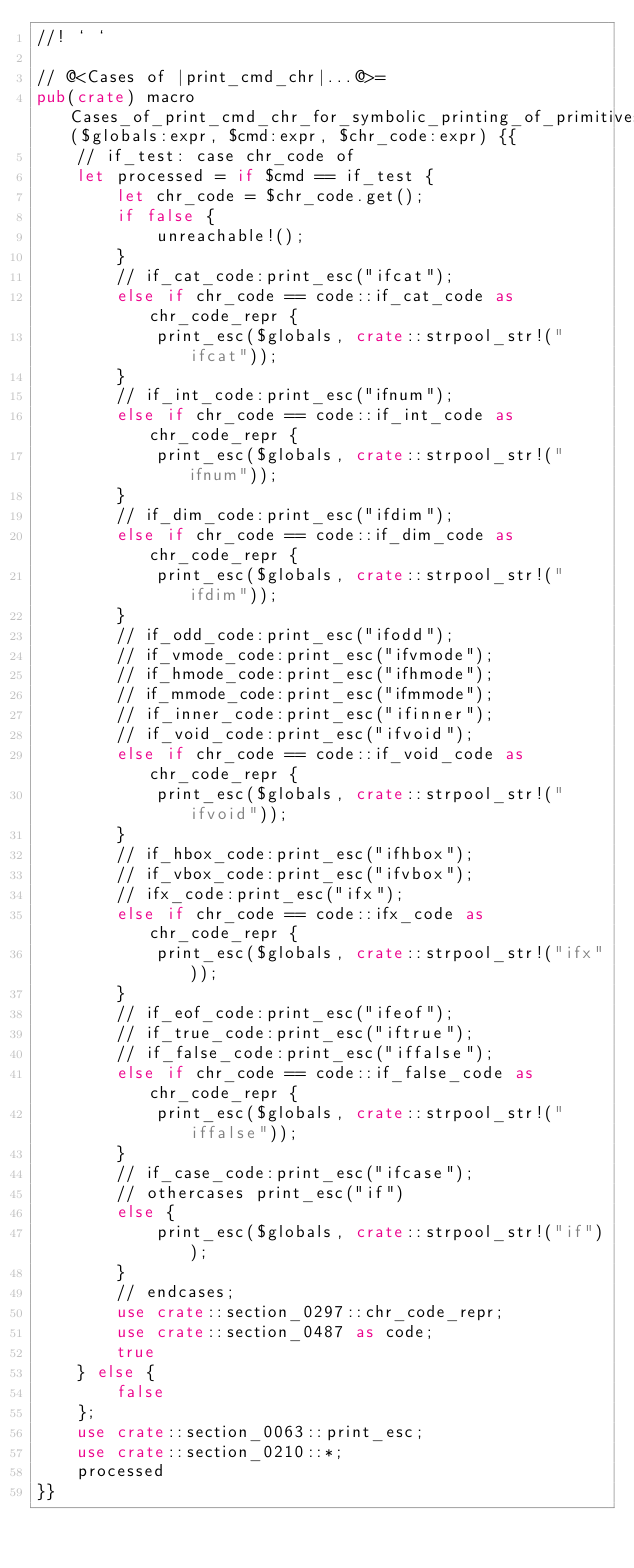Convert code to text. <code><loc_0><loc_0><loc_500><loc_500><_Rust_>//! ` `

// @<Cases of |print_cmd_chr|...@>=
pub(crate) macro Cases_of_print_cmd_chr_for_symbolic_printing_of_primitives_0488($globals:expr, $cmd:expr, $chr_code:expr) {{
    // if_test: case chr_code of
    let processed = if $cmd == if_test {
        let chr_code = $chr_code.get();
        if false {
            unreachable!();
        }
        // if_cat_code:print_esc("ifcat");
        else if chr_code == code::if_cat_code as chr_code_repr {
            print_esc($globals, crate::strpool_str!("ifcat"));
        }
        // if_int_code:print_esc("ifnum");
        else if chr_code == code::if_int_code as chr_code_repr {
            print_esc($globals, crate::strpool_str!("ifnum"));
        }
        // if_dim_code:print_esc("ifdim");
        else if chr_code == code::if_dim_code as chr_code_repr {
            print_esc($globals, crate::strpool_str!("ifdim"));
        }
        // if_odd_code:print_esc("ifodd");
        // if_vmode_code:print_esc("ifvmode");
        // if_hmode_code:print_esc("ifhmode");
        // if_mmode_code:print_esc("ifmmode");
        // if_inner_code:print_esc("ifinner");
        // if_void_code:print_esc("ifvoid");
        else if chr_code == code::if_void_code as chr_code_repr {
            print_esc($globals, crate::strpool_str!("ifvoid"));
        }
        // if_hbox_code:print_esc("ifhbox");
        // if_vbox_code:print_esc("ifvbox");
        // ifx_code:print_esc("ifx");
        else if chr_code == code::ifx_code as chr_code_repr {
            print_esc($globals, crate::strpool_str!("ifx"));
        }
        // if_eof_code:print_esc("ifeof");
        // if_true_code:print_esc("iftrue");
        // if_false_code:print_esc("iffalse");
        else if chr_code == code::if_false_code as chr_code_repr {
            print_esc($globals, crate::strpool_str!("iffalse"));
        }
        // if_case_code:print_esc("ifcase");
        // othercases print_esc("if")
        else {
            print_esc($globals, crate::strpool_str!("if"));
        }
        // endcases;
        use crate::section_0297::chr_code_repr;
        use crate::section_0487 as code;
        true
    } else {
        false
    };
    use crate::section_0063::print_esc;
    use crate::section_0210::*;
    processed
}}
</code> 